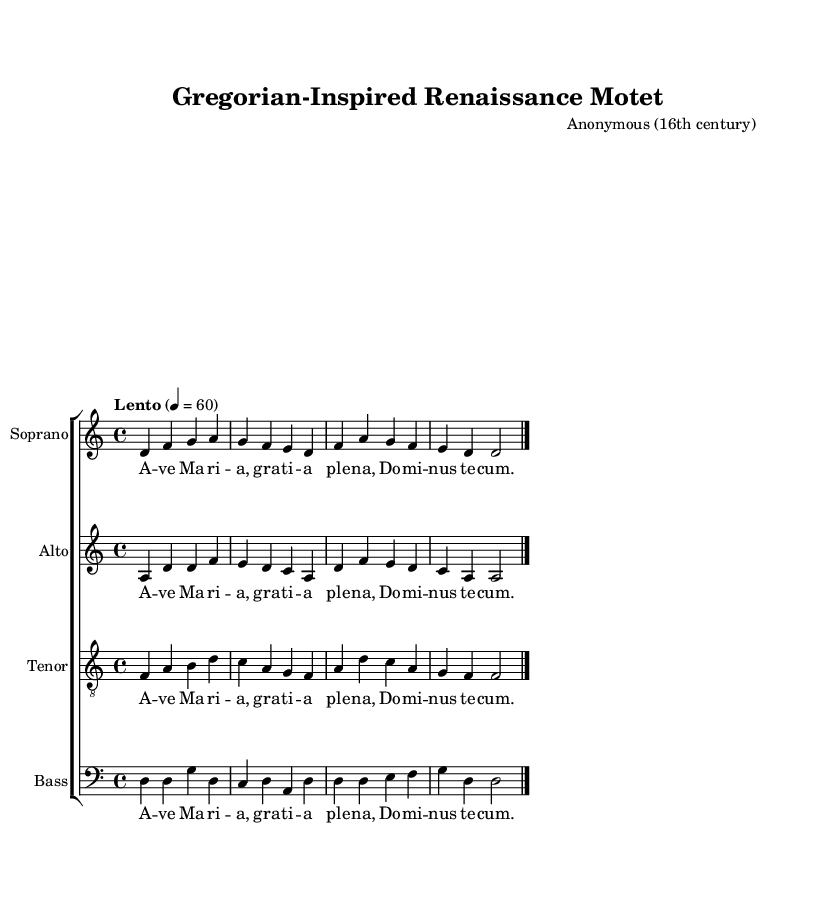What is the key signature of this music? The key signature is based on the music that is set in D Dorian. The presence of F# indicates the Dorian mode.
Answer: D Dorian What is the time signature of this music? The time signature is indicated at the beginning of the score as 4/4, which means there are four beats in each measure and the quarter note gets one beat.
Answer: 4/4 What is the tempo marking for this piece? The tempo marking at the beginning specifies "Lento," which typically indicates a slow tempo, and is quantified as quarter note equals 60 beats per minute.
Answer: Lento How many distinct vocal parts are present in this score? There are four distinct vocal parts: Soprano, Alto, Tenor, and Bass, as indicated by the designations in the staff names.
Answer: Four What text is provided as lyrics for the choir? The lyrics provided include the text "Ave Maria, gratia plena, Dominus tecum," which is a traditional liturgical phrase addressed to the Virgin Mary.
Answer: Ave Maria, gratia plena, Dominus tecum Which musical texture is predominant in this piece? The piece exhibits a polyphonic texture, characterized by multiple independent melodies being sung simultaneously, as seen across the soprano, alto, tenor, and bass parts.
Answer: Polyphonic What is a prominent feature of the musical style reflected in this piece? This piece reflects elements of Gregorian chant, which is evidenced by its modal tonality and use of plainchant-like melodies, characteristic of both Medieval and Renaissance sacred music.
Answer: Gregorian chant 